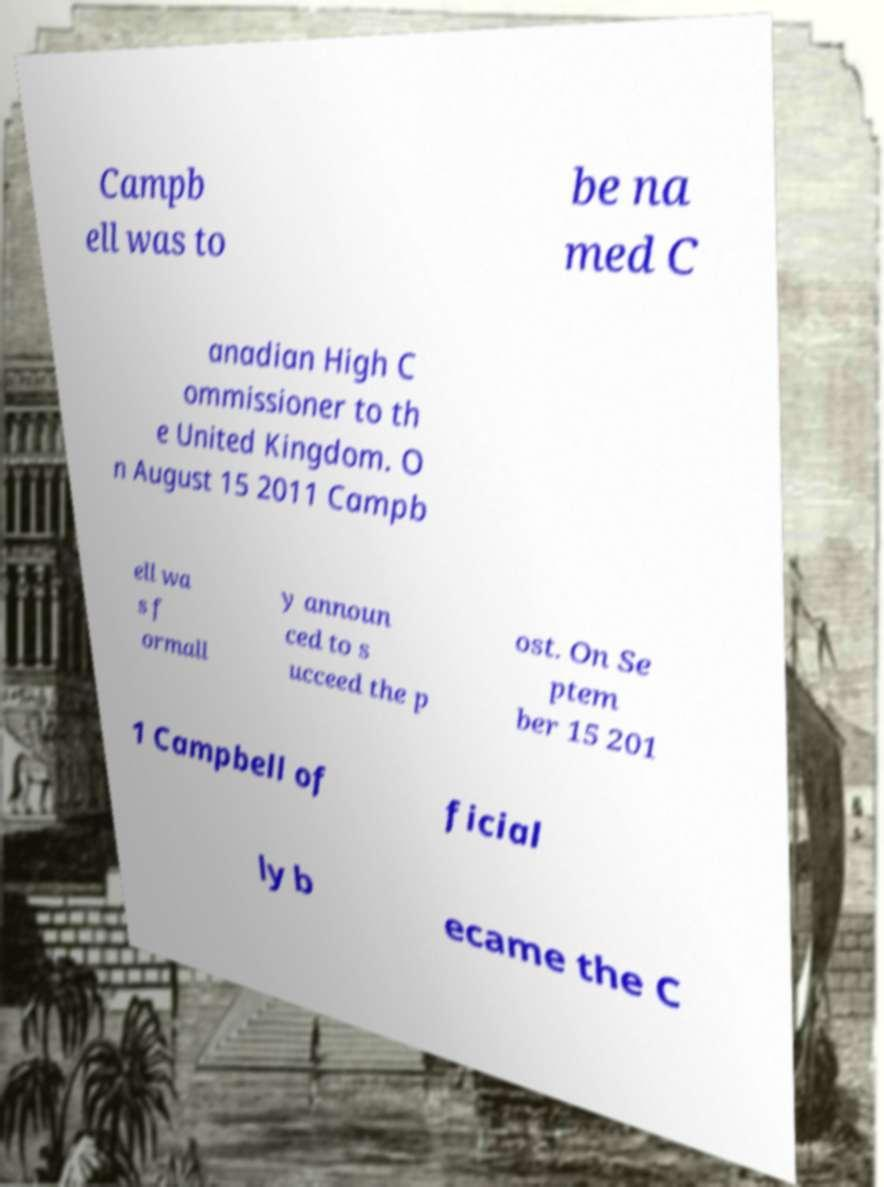Can you read and provide the text displayed in the image?This photo seems to have some interesting text. Can you extract and type it out for me? Campb ell was to be na med C anadian High C ommissioner to th e United Kingdom. O n August 15 2011 Campb ell wa s f ormall y announ ced to s ucceed the p ost. On Se ptem ber 15 201 1 Campbell of ficial ly b ecame the C 